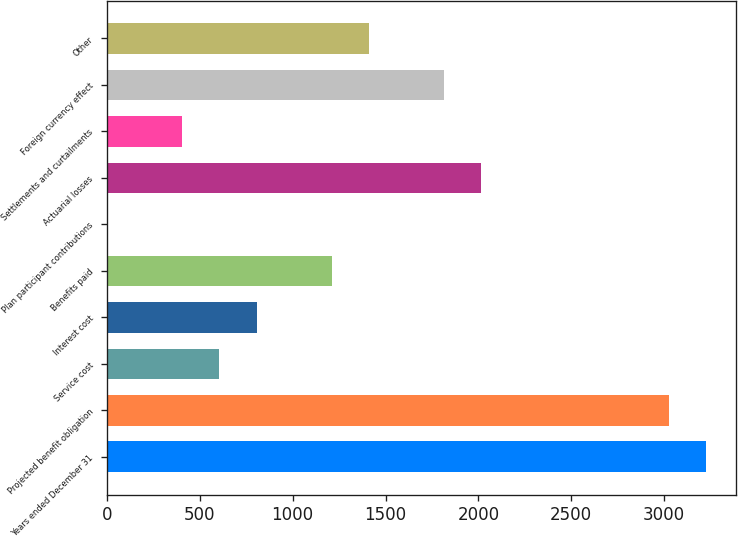Convert chart. <chart><loc_0><loc_0><loc_500><loc_500><bar_chart><fcel>Years ended December 31<fcel>Projected benefit obligation<fcel>Service cost<fcel>Interest cost<fcel>Benefits paid<fcel>Plan participant contributions<fcel>Actuarial losses<fcel>Settlements and curtailments<fcel>Foreign currency effect<fcel>Other<nl><fcel>3225.48<fcel>3023.9<fcel>604.94<fcel>806.52<fcel>1209.68<fcel>0.2<fcel>2016<fcel>403.36<fcel>1814.42<fcel>1411.26<nl></chart> 